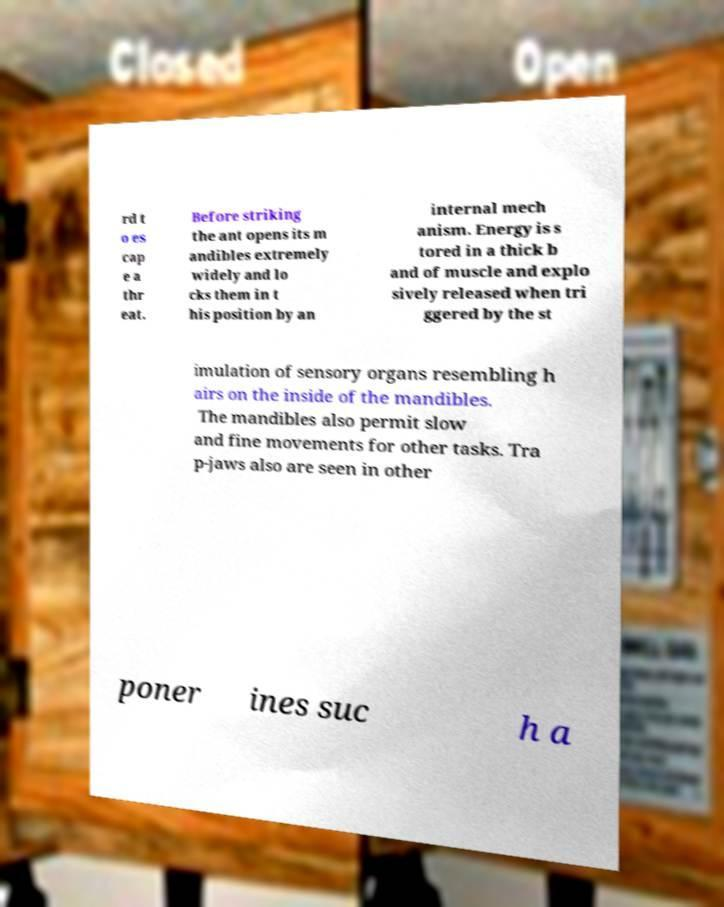Can you accurately transcribe the text from the provided image for me? rd t o es cap e a thr eat. Before striking the ant opens its m andibles extremely widely and lo cks them in t his position by an internal mech anism. Energy is s tored in a thick b and of muscle and explo sively released when tri ggered by the st imulation of sensory organs resembling h airs on the inside of the mandibles. The mandibles also permit slow and fine movements for other tasks. Tra p-jaws also are seen in other poner ines suc h a 